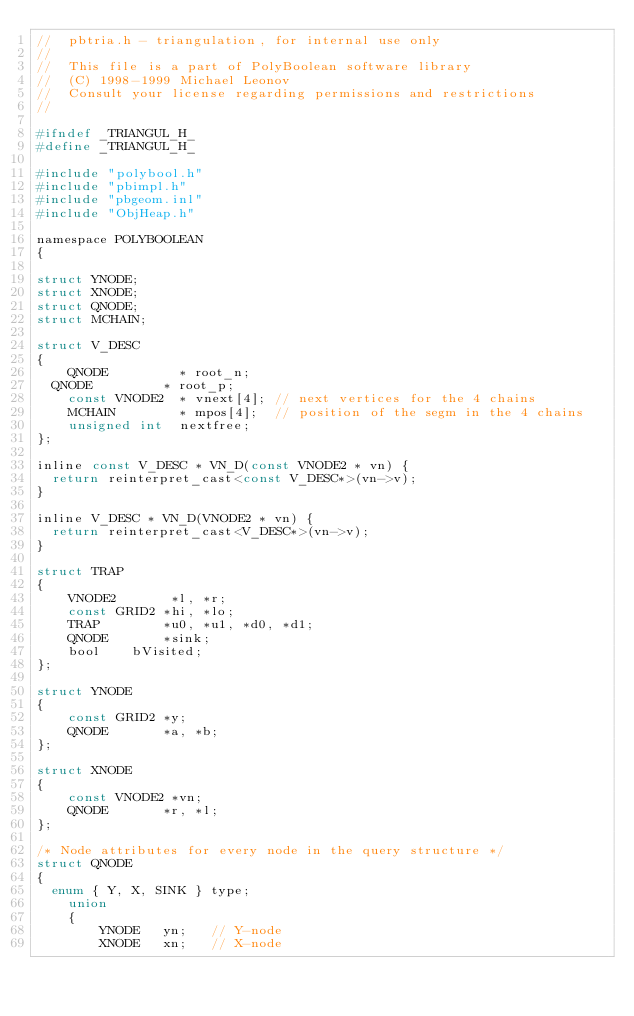Convert code to text. <code><loc_0><loc_0><loc_500><loc_500><_C_>//	pbtria.h - triangulation, for internal use only
//
//	This file is a part of PolyBoolean software library
//	(C) 1998-1999 Michael Leonov
//	Consult your license regarding permissions and restrictions
//

#ifndef _TRIANGUL_H_
#define _TRIANGUL_H_

#include "polybool.h"
#include "pbimpl.h"
#include "pbgeom.inl"
#include "ObjHeap.h"

namespace POLYBOOLEAN
{

struct YNODE;
struct XNODE;
struct QNODE;
struct MCHAIN;

struct V_DESC
{
    QNODE         *	root_n;
	QNODE         *	root_p;
    const VNODE2  *	vnext[4];	// next vertices for the 4 chains
    MCHAIN        *	mpos[4];	// position of the segm in the 4 chains
    unsigned int	nextfree;
};

inline const V_DESC * VN_D(const VNODE2 * vn) {
	return reinterpret_cast<const V_DESC*>(vn->v);
}

inline V_DESC * VN_D(VNODE2 * vn) {
	return reinterpret_cast<V_DESC*>(vn->v);
}

struct TRAP
{
    VNODE2       *l, *r;
    const GRID2 *hi, *lo;
    TRAP        *u0, *u1, *d0, *d1;
    QNODE       *sink;
    bool		bVisited;
};

struct YNODE
{
    const GRID2 *y;
    QNODE       *a, *b;
};

struct XNODE
{
    const VNODE2 *vn;
    QNODE       *r, *l;
};

/* Node attributes for every node in the query structure */
struct QNODE
{
	enum { Y, X, SINK } type;
    union
    {
        YNODE   yn;		// Y-node
        XNODE   xn;		// X-node</code> 